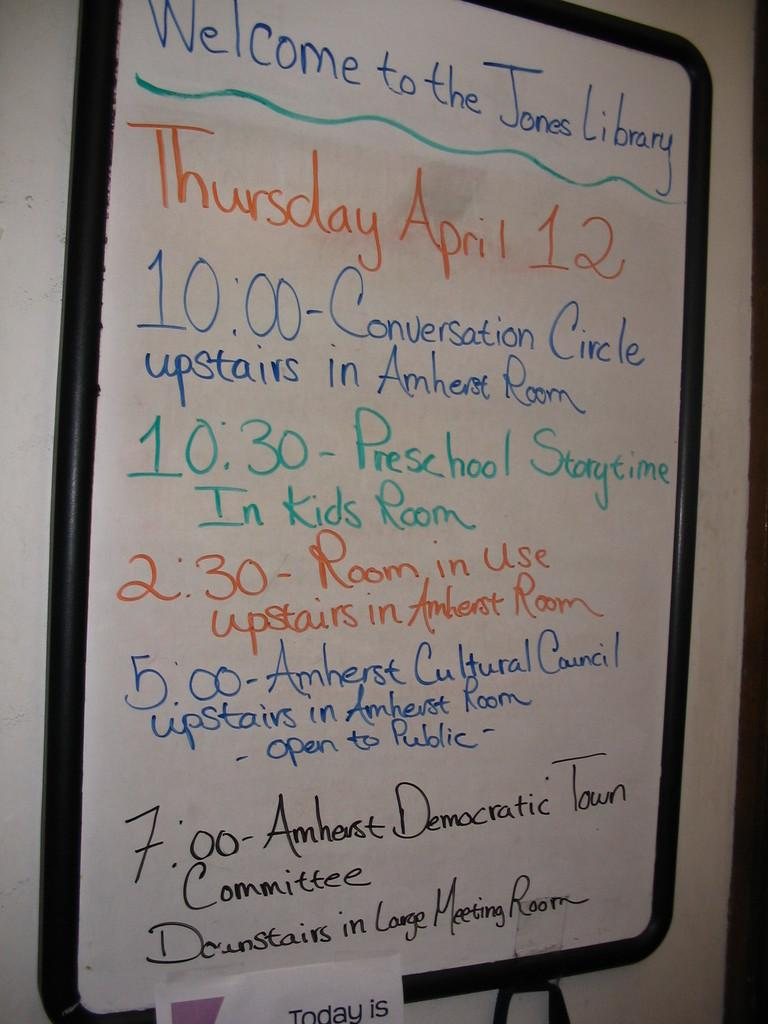<image>
Write a terse but informative summary of the picture. A white board that says "Welcome to the Jones Library" and shows a schedule. 